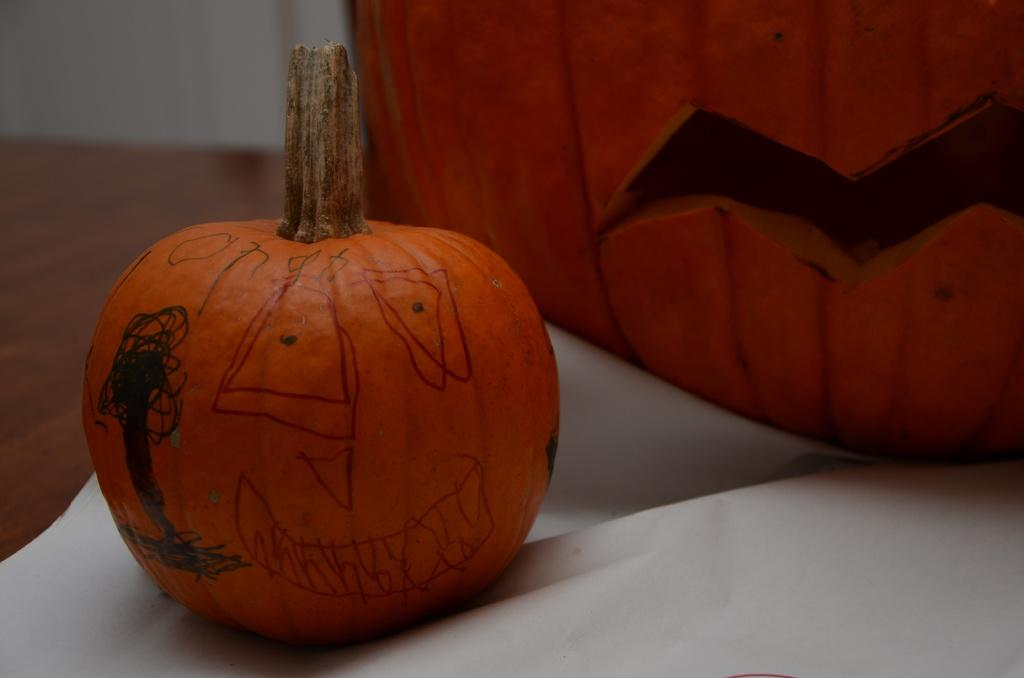What objects are present in the image? There are pumpkins in the image. How are the pumpkins arranged or placed? The pumpkins are on top of a paper. What is the surface beneath the paper? The paper is on a wooden surface. What can be seen in the background of the image? There is a wall visible in the top left corner of the image. Can you see any toads swimming in the lake in the image? There is no lake or toads present in the image; it features pumpkins on a paper on a wooden surface with a wall visible in the background. 